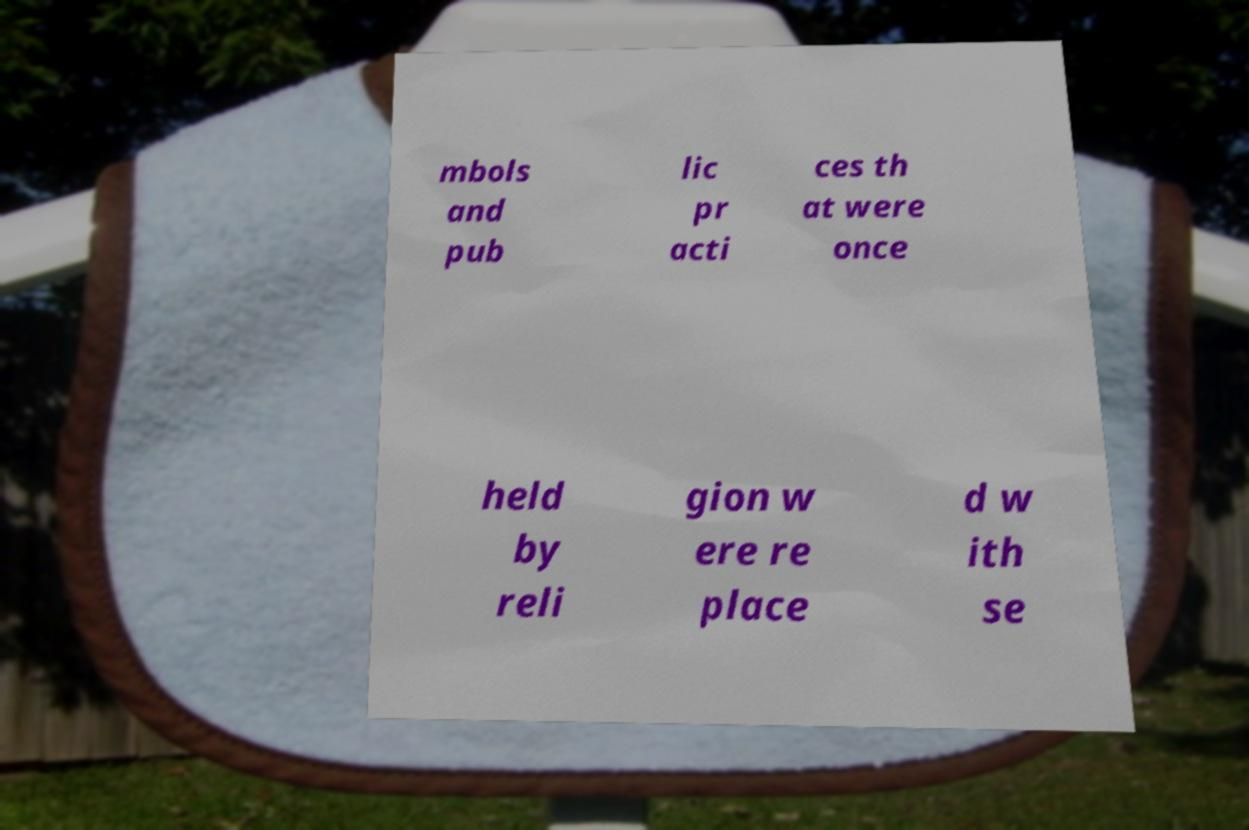I need the written content from this picture converted into text. Can you do that? mbols and pub lic pr acti ces th at were once held by reli gion w ere re place d w ith se 